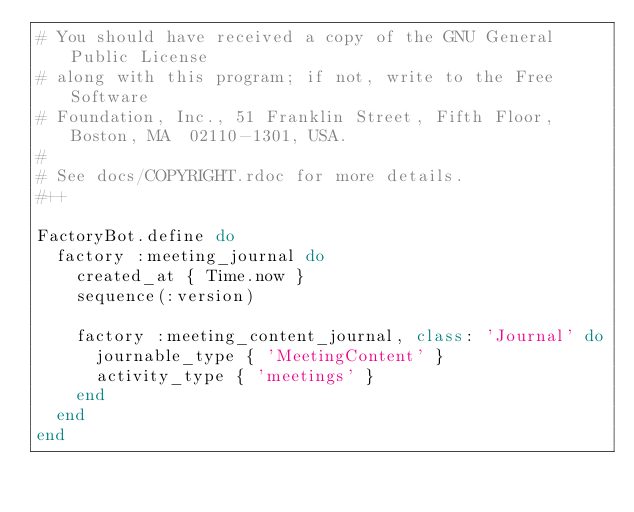<code> <loc_0><loc_0><loc_500><loc_500><_Ruby_># You should have received a copy of the GNU General Public License
# along with this program; if not, write to the Free Software
# Foundation, Inc., 51 Franklin Street, Fifth Floor, Boston, MA  02110-1301, USA.
#
# See docs/COPYRIGHT.rdoc for more details.
#++

FactoryBot.define do
  factory :meeting_journal do
    created_at { Time.now }
    sequence(:version)

    factory :meeting_content_journal, class: 'Journal' do
      journable_type { 'MeetingContent' }
      activity_type { 'meetings' }
    end
  end
end
</code> 